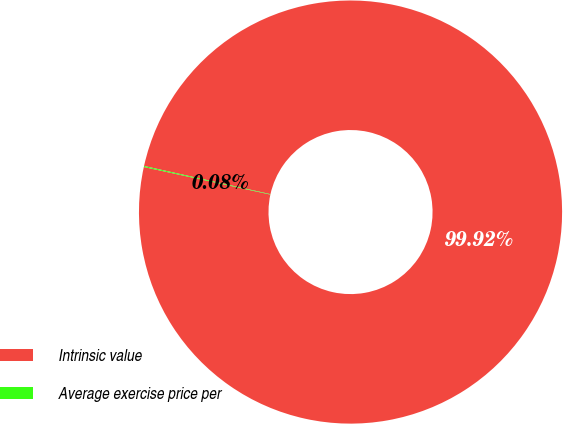<chart> <loc_0><loc_0><loc_500><loc_500><pie_chart><fcel>Intrinsic value<fcel>Average exercise price per<nl><fcel>99.92%<fcel>0.08%<nl></chart> 